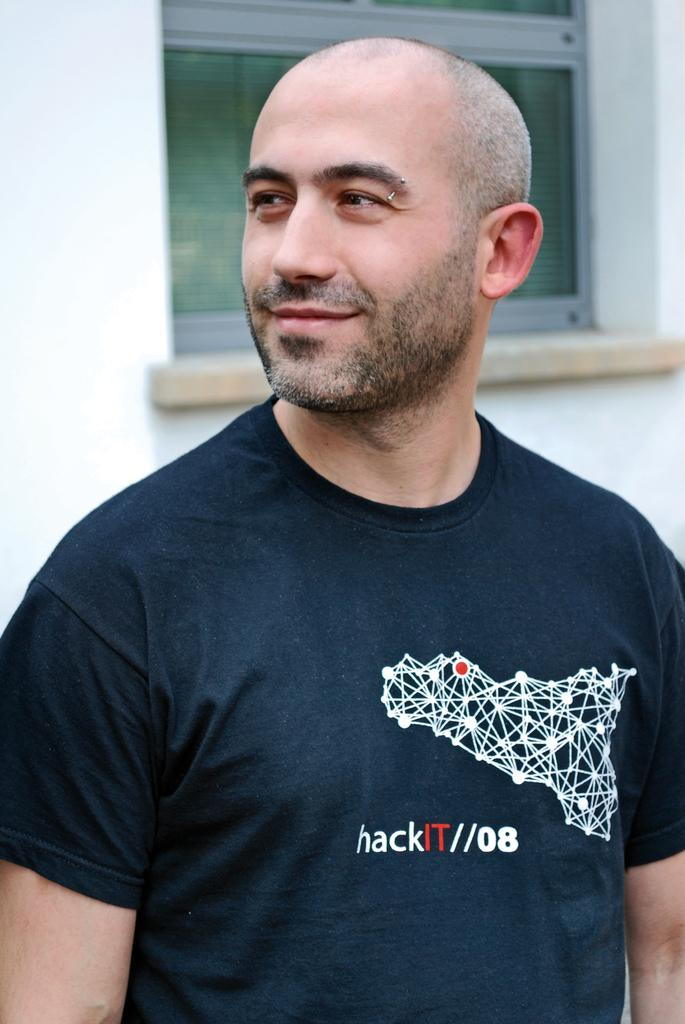Who or what is present in the image? There is a person in the image. What is the person doing or expressing? The person is smiling. Can you describe the background of the image? The background of the image is blurred. What can be seen in the background of the image? There is a wall and a window in the background of the image. What type of bun is the person holding in the image? There is no bun present in the image. Who is the owner of the window in the image? The image does not provide information about the ownership of the window. 